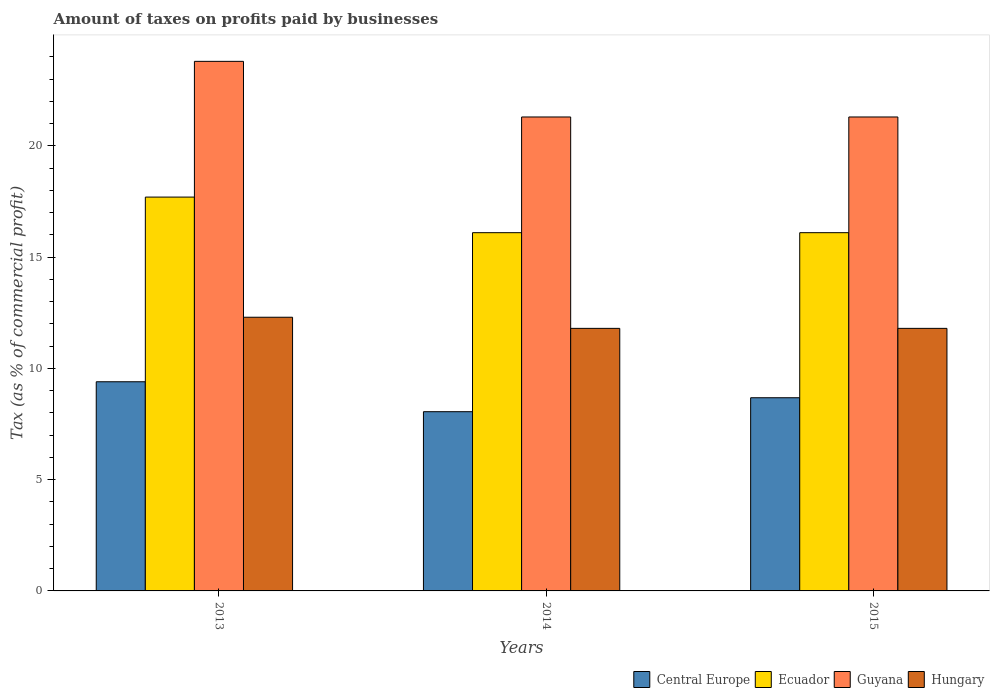How many different coloured bars are there?
Offer a terse response. 4. How many groups of bars are there?
Give a very brief answer. 3. Are the number of bars on each tick of the X-axis equal?
Ensure brevity in your answer.  Yes. How many bars are there on the 2nd tick from the left?
Ensure brevity in your answer.  4. In how many cases, is the number of bars for a given year not equal to the number of legend labels?
Your response must be concise. 0. What is the percentage of taxes paid by businesses in Ecuador in 2015?
Provide a short and direct response. 16.1. Across all years, what is the maximum percentage of taxes paid by businesses in Guyana?
Your response must be concise. 23.8. In which year was the percentage of taxes paid by businesses in Central Europe maximum?
Offer a very short reply. 2013. What is the total percentage of taxes paid by businesses in Central Europe in the graph?
Offer a very short reply. 26.14. What is the difference between the percentage of taxes paid by businesses in Guyana in 2014 and that in 2015?
Offer a very short reply. 0. What is the difference between the percentage of taxes paid by businesses in Guyana in 2015 and the percentage of taxes paid by businesses in Ecuador in 2013?
Provide a succinct answer. 3.6. What is the average percentage of taxes paid by businesses in Guyana per year?
Offer a terse response. 22.13. In the year 2014, what is the difference between the percentage of taxes paid by businesses in Central Europe and percentage of taxes paid by businesses in Guyana?
Your response must be concise. -13.25. In how many years, is the percentage of taxes paid by businesses in Central Europe greater than 10 %?
Your answer should be compact. 0. What is the ratio of the percentage of taxes paid by businesses in Ecuador in 2014 to that in 2015?
Keep it short and to the point. 1. Is the percentage of taxes paid by businesses in Hungary in 2013 less than that in 2014?
Offer a terse response. No. Is the difference between the percentage of taxes paid by businesses in Central Europe in 2014 and 2015 greater than the difference between the percentage of taxes paid by businesses in Guyana in 2014 and 2015?
Offer a terse response. No. What is the difference between the highest and the lowest percentage of taxes paid by businesses in Hungary?
Ensure brevity in your answer.  0.5. In how many years, is the percentage of taxes paid by businesses in Guyana greater than the average percentage of taxes paid by businesses in Guyana taken over all years?
Provide a succinct answer. 1. Is the sum of the percentage of taxes paid by businesses in Ecuador in 2014 and 2015 greater than the maximum percentage of taxes paid by businesses in Guyana across all years?
Offer a very short reply. Yes. What does the 1st bar from the left in 2013 represents?
Give a very brief answer. Central Europe. What does the 4th bar from the right in 2013 represents?
Offer a terse response. Central Europe. Is it the case that in every year, the sum of the percentage of taxes paid by businesses in Central Europe and percentage of taxes paid by businesses in Hungary is greater than the percentage of taxes paid by businesses in Ecuador?
Keep it short and to the point. Yes. How many bars are there?
Offer a terse response. 12. Are all the bars in the graph horizontal?
Provide a succinct answer. No. How many years are there in the graph?
Offer a very short reply. 3. Where does the legend appear in the graph?
Your response must be concise. Bottom right. How many legend labels are there?
Make the answer very short. 4. How are the legend labels stacked?
Ensure brevity in your answer.  Horizontal. What is the title of the graph?
Ensure brevity in your answer.  Amount of taxes on profits paid by businesses. Does "China" appear as one of the legend labels in the graph?
Keep it short and to the point. No. What is the label or title of the X-axis?
Your answer should be compact. Years. What is the label or title of the Y-axis?
Provide a succinct answer. Tax (as % of commercial profit). What is the Tax (as % of commercial profit) in Ecuador in 2013?
Make the answer very short. 17.7. What is the Tax (as % of commercial profit) in Guyana in 2013?
Your answer should be compact. 23.8. What is the Tax (as % of commercial profit) in Central Europe in 2014?
Provide a succinct answer. 8.05. What is the Tax (as % of commercial profit) in Ecuador in 2014?
Provide a short and direct response. 16.1. What is the Tax (as % of commercial profit) in Guyana in 2014?
Make the answer very short. 21.3. What is the Tax (as % of commercial profit) in Central Europe in 2015?
Provide a succinct answer. 8.68. What is the Tax (as % of commercial profit) of Ecuador in 2015?
Provide a succinct answer. 16.1. What is the Tax (as % of commercial profit) of Guyana in 2015?
Offer a terse response. 21.3. What is the Tax (as % of commercial profit) of Hungary in 2015?
Provide a short and direct response. 11.8. Across all years, what is the maximum Tax (as % of commercial profit) of Guyana?
Give a very brief answer. 23.8. Across all years, what is the maximum Tax (as % of commercial profit) of Hungary?
Make the answer very short. 12.3. Across all years, what is the minimum Tax (as % of commercial profit) of Central Europe?
Ensure brevity in your answer.  8.05. Across all years, what is the minimum Tax (as % of commercial profit) of Ecuador?
Give a very brief answer. 16.1. Across all years, what is the minimum Tax (as % of commercial profit) of Guyana?
Provide a short and direct response. 21.3. What is the total Tax (as % of commercial profit) in Central Europe in the graph?
Your answer should be compact. 26.14. What is the total Tax (as % of commercial profit) of Ecuador in the graph?
Ensure brevity in your answer.  49.9. What is the total Tax (as % of commercial profit) in Guyana in the graph?
Make the answer very short. 66.4. What is the total Tax (as % of commercial profit) in Hungary in the graph?
Offer a very short reply. 35.9. What is the difference between the Tax (as % of commercial profit) of Central Europe in 2013 and that in 2014?
Provide a short and direct response. 1.35. What is the difference between the Tax (as % of commercial profit) in Central Europe in 2013 and that in 2015?
Make the answer very short. 0.72. What is the difference between the Tax (as % of commercial profit) in Ecuador in 2013 and that in 2015?
Offer a very short reply. 1.6. What is the difference between the Tax (as % of commercial profit) of Guyana in 2013 and that in 2015?
Your answer should be compact. 2.5. What is the difference between the Tax (as % of commercial profit) of Central Europe in 2014 and that in 2015?
Your answer should be compact. -0.63. What is the difference between the Tax (as % of commercial profit) in Hungary in 2014 and that in 2015?
Your answer should be compact. 0. What is the difference between the Tax (as % of commercial profit) in Central Europe in 2013 and the Tax (as % of commercial profit) in Guyana in 2014?
Provide a short and direct response. -11.9. What is the difference between the Tax (as % of commercial profit) in Guyana in 2013 and the Tax (as % of commercial profit) in Hungary in 2014?
Provide a short and direct response. 12. What is the difference between the Tax (as % of commercial profit) in Ecuador in 2013 and the Tax (as % of commercial profit) in Hungary in 2015?
Give a very brief answer. 5.9. What is the difference between the Tax (as % of commercial profit) of Guyana in 2013 and the Tax (as % of commercial profit) of Hungary in 2015?
Keep it short and to the point. 12. What is the difference between the Tax (as % of commercial profit) in Central Europe in 2014 and the Tax (as % of commercial profit) in Ecuador in 2015?
Offer a very short reply. -8.05. What is the difference between the Tax (as % of commercial profit) of Central Europe in 2014 and the Tax (as % of commercial profit) of Guyana in 2015?
Keep it short and to the point. -13.25. What is the difference between the Tax (as % of commercial profit) of Central Europe in 2014 and the Tax (as % of commercial profit) of Hungary in 2015?
Ensure brevity in your answer.  -3.75. What is the average Tax (as % of commercial profit) in Central Europe per year?
Your answer should be compact. 8.71. What is the average Tax (as % of commercial profit) in Ecuador per year?
Your answer should be compact. 16.63. What is the average Tax (as % of commercial profit) of Guyana per year?
Your answer should be compact. 22.13. What is the average Tax (as % of commercial profit) in Hungary per year?
Provide a succinct answer. 11.97. In the year 2013, what is the difference between the Tax (as % of commercial profit) of Central Europe and Tax (as % of commercial profit) of Guyana?
Offer a very short reply. -14.4. In the year 2013, what is the difference between the Tax (as % of commercial profit) in Ecuador and Tax (as % of commercial profit) in Hungary?
Give a very brief answer. 5.4. In the year 2013, what is the difference between the Tax (as % of commercial profit) in Guyana and Tax (as % of commercial profit) in Hungary?
Provide a short and direct response. 11.5. In the year 2014, what is the difference between the Tax (as % of commercial profit) of Central Europe and Tax (as % of commercial profit) of Ecuador?
Your response must be concise. -8.05. In the year 2014, what is the difference between the Tax (as % of commercial profit) of Central Europe and Tax (as % of commercial profit) of Guyana?
Your answer should be very brief. -13.25. In the year 2014, what is the difference between the Tax (as % of commercial profit) of Central Europe and Tax (as % of commercial profit) of Hungary?
Offer a very short reply. -3.75. In the year 2014, what is the difference between the Tax (as % of commercial profit) of Ecuador and Tax (as % of commercial profit) of Hungary?
Your response must be concise. 4.3. In the year 2014, what is the difference between the Tax (as % of commercial profit) of Guyana and Tax (as % of commercial profit) of Hungary?
Ensure brevity in your answer.  9.5. In the year 2015, what is the difference between the Tax (as % of commercial profit) of Central Europe and Tax (as % of commercial profit) of Ecuador?
Your answer should be compact. -7.42. In the year 2015, what is the difference between the Tax (as % of commercial profit) of Central Europe and Tax (as % of commercial profit) of Guyana?
Your answer should be very brief. -12.62. In the year 2015, what is the difference between the Tax (as % of commercial profit) of Central Europe and Tax (as % of commercial profit) of Hungary?
Offer a terse response. -3.12. In the year 2015, what is the difference between the Tax (as % of commercial profit) of Ecuador and Tax (as % of commercial profit) of Hungary?
Provide a short and direct response. 4.3. What is the ratio of the Tax (as % of commercial profit) in Central Europe in 2013 to that in 2014?
Make the answer very short. 1.17. What is the ratio of the Tax (as % of commercial profit) in Ecuador in 2013 to that in 2014?
Offer a terse response. 1.1. What is the ratio of the Tax (as % of commercial profit) of Guyana in 2013 to that in 2014?
Make the answer very short. 1.12. What is the ratio of the Tax (as % of commercial profit) in Hungary in 2013 to that in 2014?
Your answer should be compact. 1.04. What is the ratio of the Tax (as % of commercial profit) of Central Europe in 2013 to that in 2015?
Ensure brevity in your answer.  1.08. What is the ratio of the Tax (as % of commercial profit) in Ecuador in 2013 to that in 2015?
Your answer should be compact. 1.1. What is the ratio of the Tax (as % of commercial profit) in Guyana in 2013 to that in 2015?
Provide a succinct answer. 1.12. What is the ratio of the Tax (as % of commercial profit) in Hungary in 2013 to that in 2015?
Offer a very short reply. 1.04. What is the ratio of the Tax (as % of commercial profit) of Central Europe in 2014 to that in 2015?
Your answer should be very brief. 0.93. What is the ratio of the Tax (as % of commercial profit) of Guyana in 2014 to that in 2015?
Your answer should be very brief. 1. What is the difference between the highest and the second highest Tax (as % of commercial profit) in Central Europe?
Keep it short and to the point. 0.72. What is the difference between the highest and the second highest Tax (as % of commercial profit) in Ecuador?
Your answer should be compact. 1.6. What is the difference between the highest and the lowest Tax (as % of commercial profit) in Central Europe?
Provide a succinct answer. 1.35. What is the difference between the highest and the lowest Tax (as % of commercial profit) of Ecuador?
Offer a very short reply. 1.6. 